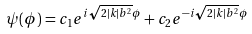Convert formula to latex. <formula><loc_0><loc_0><loc_500><loc_500>\psi ( \phi ) = c _ { 1 } e ^ { i \sqrt { 2 | k | b ^ { 2 } } \phi } + c _ { 2 } e ^ { - i \sqrt { 2 | k | b ^ { 2 } } \phi }</formula> 